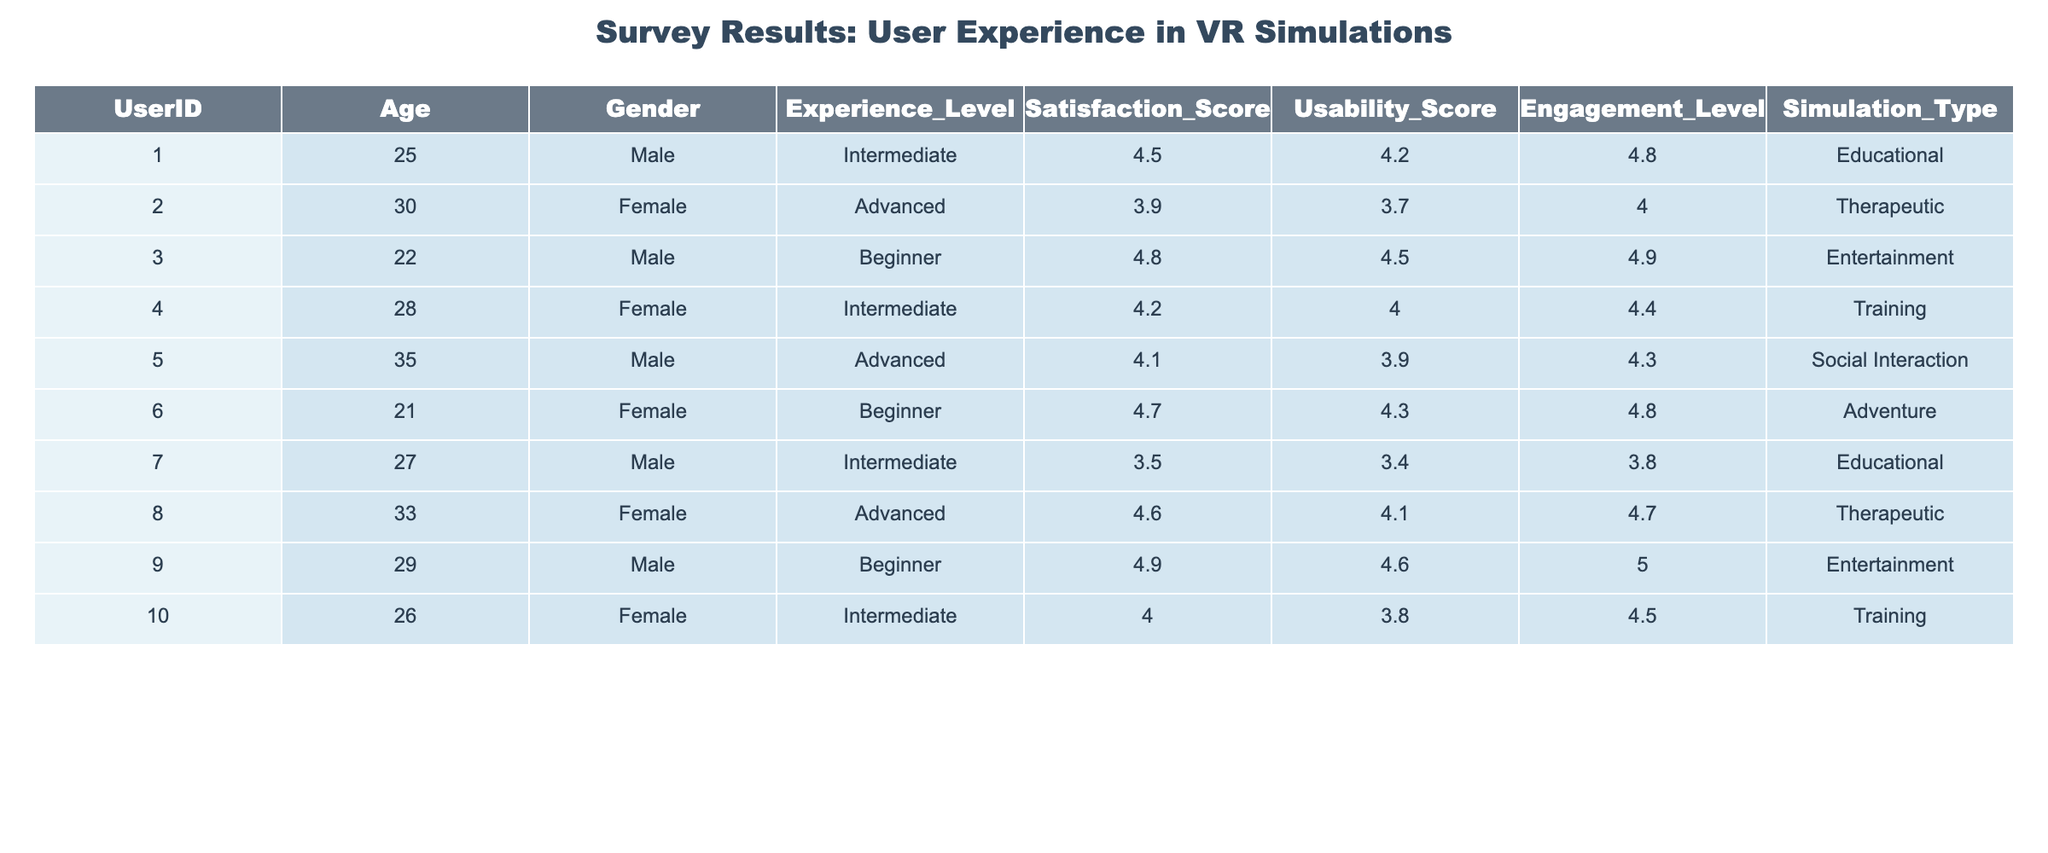What is the satisfaction score of the user with UserID 5? The table shows that the satisfaction score of the user with UserID 5 is listed directly as 4.1 in the Satisfaction_Score column.
Answer: 4.1 What is the average usability score for users with an Advanced experience level? The users with an Advanced experience level are UserID 2 (3.7), UserID 5 (3.9), and UserID 8 (4.1). To find the average, we sum these scores: (3.7 + 3.9 + 4.1) = 11.7, and then divide by 3, giving us 11.7 / 3 = 3.9.
Answer: 3.9 Is the engagement level of the user with UserID 4 greater than 4.5? The engagement level for UserID 4 is 4.4, which is not greater than 4.5. Therefore, the statement is false.
Answer: False What is the highest satisfaction score recorded in the survey? By examining all rows in the Satisfaction_Score column, UserID 9 has the highest score, which is 4.9.
Answer: 4.9 How many users reported a satisfaction score of 4.5 or higher? The users with a satisfaction score of 4.5 or higher are UserID 1 (4.5), UserID 3 (4.8), UserID 6 (4.7), UserID 8 (4.6), and UserID 9 (4.9). Counting these, there are 5 users.
Answer: 5 What is the difference between the highest and lowest usability scores? The highest usability score is 4.6 (UserID 9) and the lowest is 3.4 (UserID 7). The difference is calculated as 4.6 - 3.4 = 1.2.
Answer: 1.2 Which simulation type had the lowest average engagement level? The engagement levels by simulation type are: Educational (mean 4.1), Therapeutic (mean 4.4), Entertainment (mean 4.9), Training (mean 4.5), and Social Interaction (mean 4.3). The Educational type has the lowest average engagement level of 4.1.
Answer: Educational Are there any beginners who reported a satisfaction score above 4.5? UserID 3 (satisfaction score 4.8) and UserID 9 (satisfaction score 4.9) are both beginners who reported scores above 4.5. Thus, the answer is yes.
Answer: Yes How does the satisfaction score of Intermediate users compare to Advanced users? Intermediate users are UserID 1 (4.5), UserID 4 (4.2), UserID 7 (3.5), and UserID 10 (4.0), with an average of (4.5 + 4.2 + 3.5 + 4.0) / 4 = 4.05. Advanced users are UserID 2 (3.9), UserID 5 (4.1), and UserID 8 (4.6), with an average of (3.9 + 4.1 + 4.6) / 3 = 4.2. Advanced users have a higher average satisfaction score than Intermediate users.
Answer: Advanced users have a higher average satisfaction score 